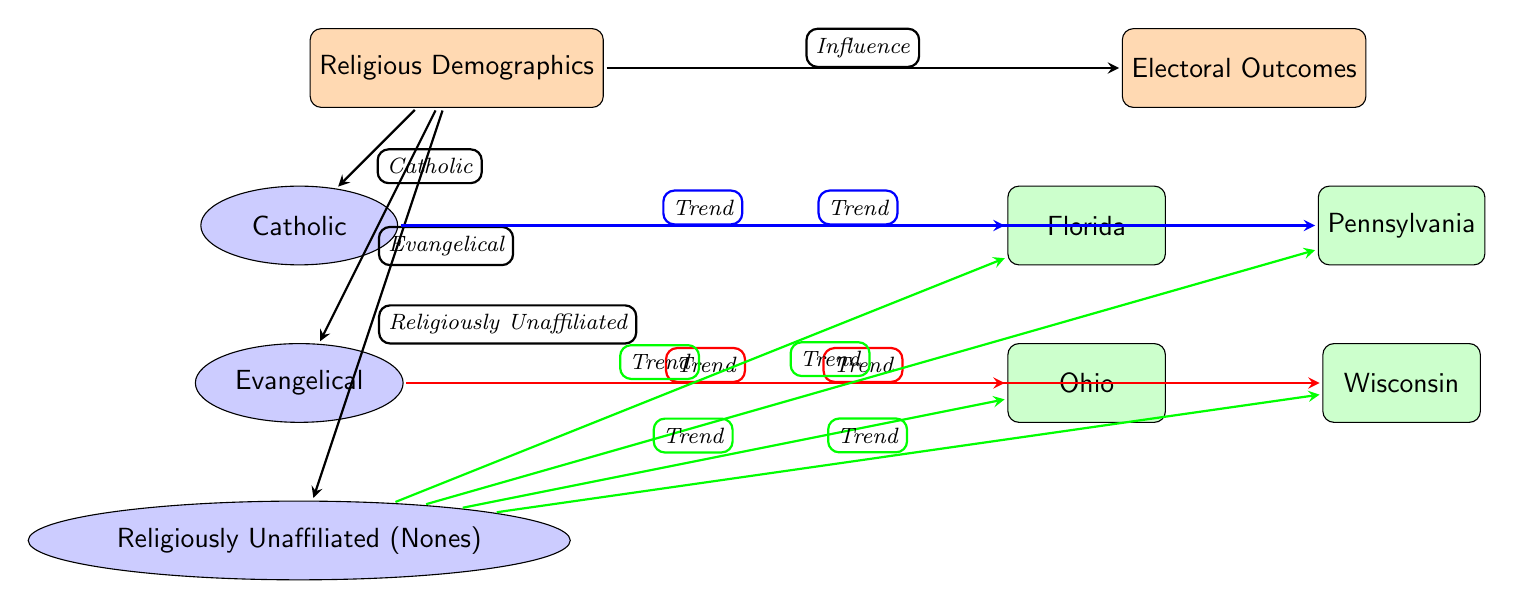What is the main focus of the diagram? The main focus of the diagram is indicated by the title and the central node, which is "Religious Demographics." It serves as the anchor for the connections made to electoral outcomes.
Answer: Religious Demographics How many states are represented in the diagram? There are four states illustrated in the diagram: Florida, Pennsylvania, Ohio, and Wisconsin. This is noted in the state nodes positioned on the right side.
Answer: Four Which demographic group is associated with Florida? The demographic group associated with Florida includes Catholics and the Religiously Unaffiliated (Nones), as shown by the arrows leading from these nodes to Florida.
Answer: Catholics, Religiously Unaffiliated (Nones) What type of trend is associated with Evangelicals in Ohio? The trend associated with Evangelicals in Ohio is indicated by the arrow that points toward Ohio from the Evangelical node, denoting a specific influence on the state's electoral outcome.
Answer: Trend Which demographic group shows a trend in all four states? The Religiously Unaffiliated (Nones) demographic group shows a trend in all four states, as indicated by the arrows leading from this node to Florida, Pennsylvania, Ohio, and Wisconsin.
Answer: Religiously Unaffiliated (Nones) What color denotes the trends associated with Catholics? The color that denotes the trends associated with Catholics is blue, as represented by the arrows connecting from the Catholic node to the states.
Answer: Blue How do the Evangelicals specifically influence Wisconsin's electoral outcome? The influence of Evangelicals on Wisconsin's electoral outcome is shown by the red arrow emanating from the Evangelical node pointing directly to Wisconsin; thus, it indicates a trend associated with this religious demographic.
Answer: Trend Which node receives trends from the Nones group? The nodes that receive trends from the Nones group are Florida, Pennsylvania, Ohio, and Wisconsin, as all are connected via arrows pointing from the Nones group.
Answer: Florida, Pennsylvania, Ohio, Wisconsin 